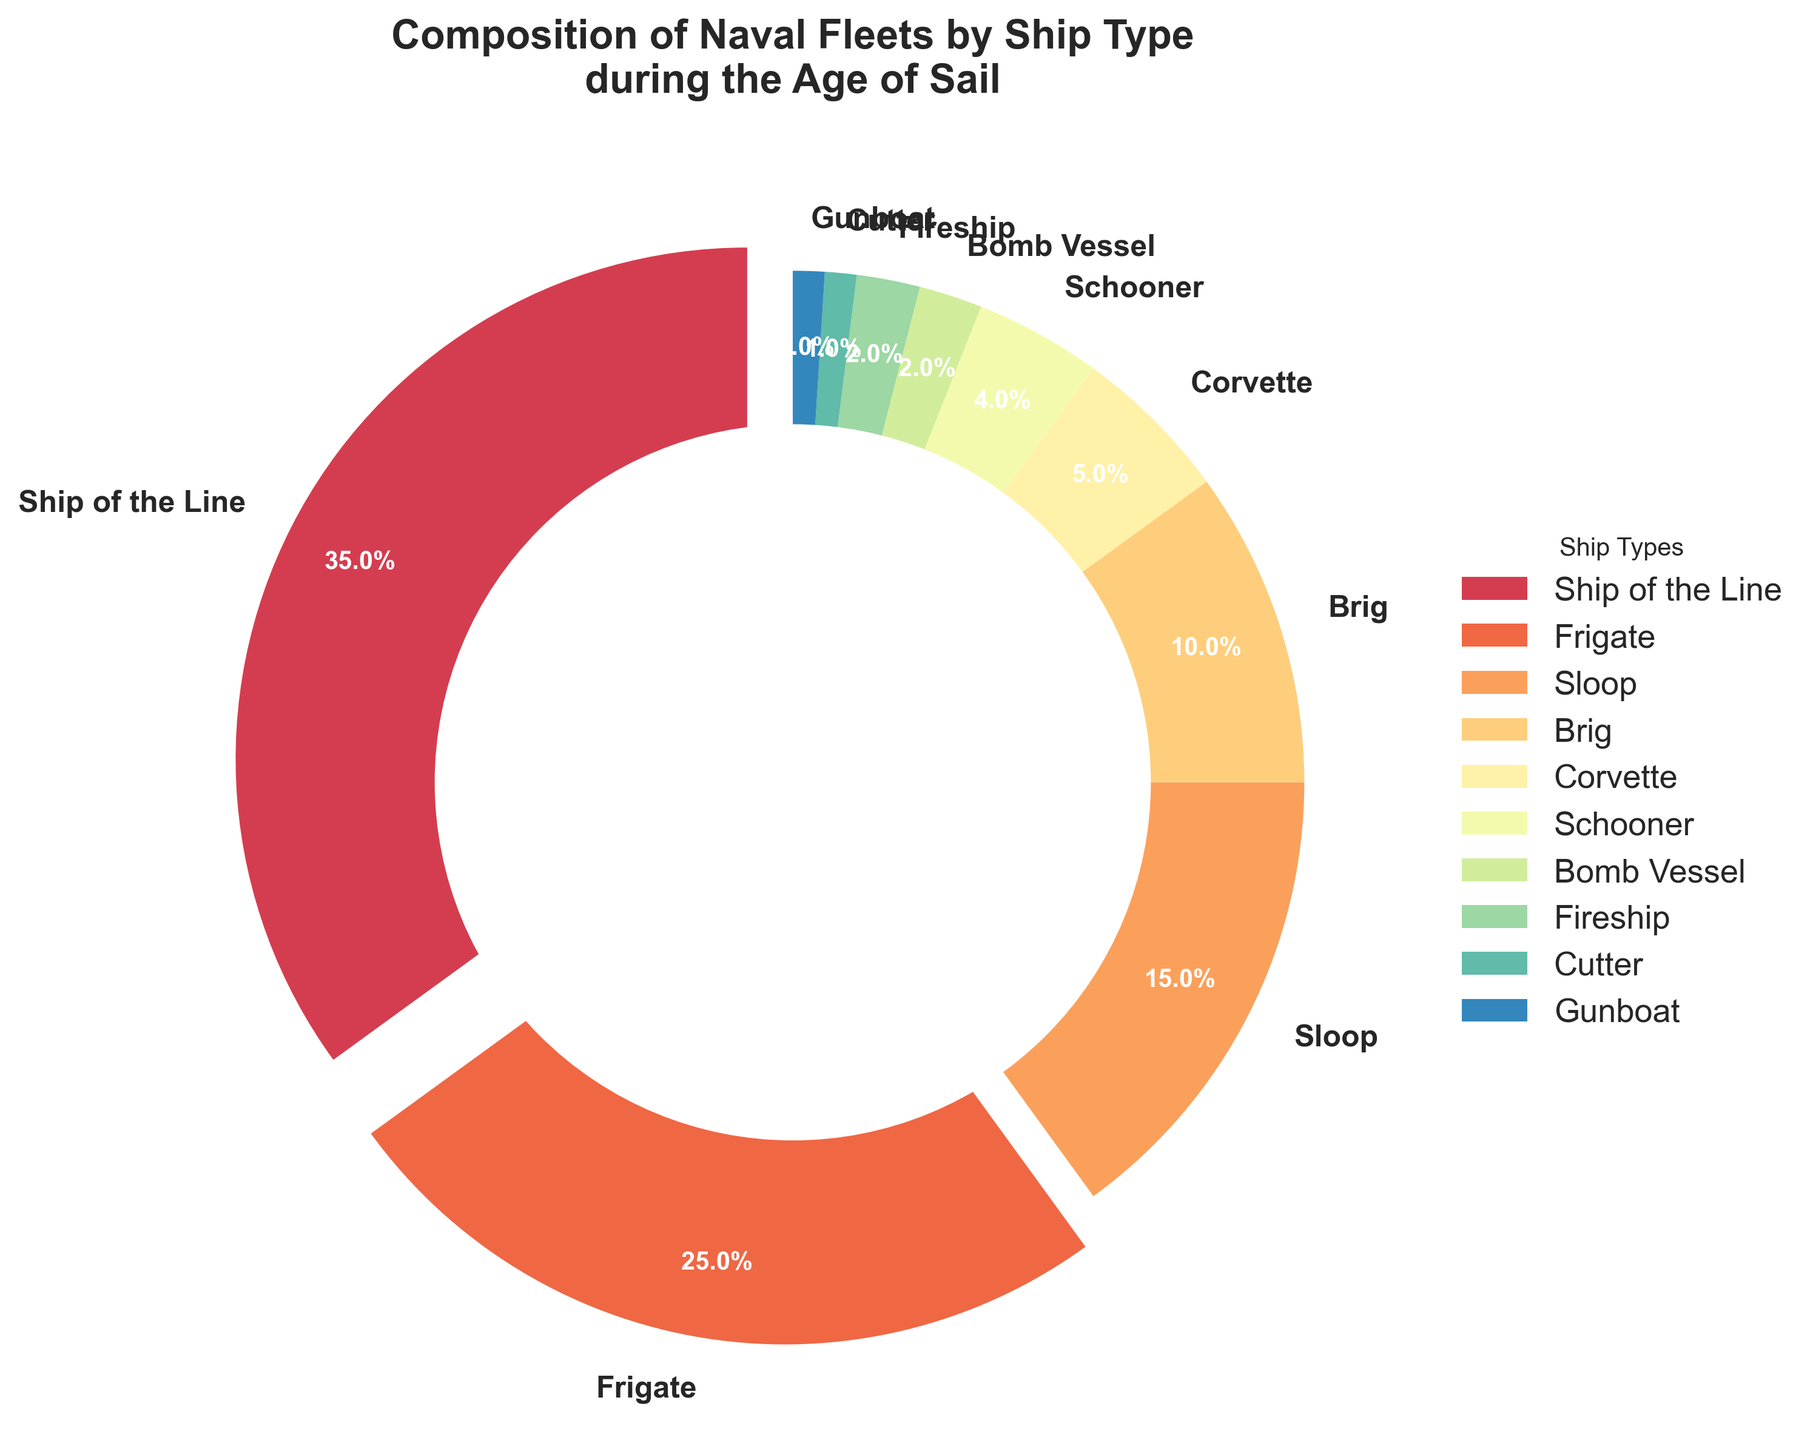What percentage of the naval fleet is comprised of Ships of the Line and Frigates combined? Sum the percentages of Ships of the Line and Frigates: 35% + 25% = 60%
Answer: 60% Which ship type has the second smallest representation in the fleet? The Cutter and Gunboat both have the smallest percentages (1%). The next smallest representation is Bomb Vessel at 2%.
Answer: Bomb Vessel Are there more Frigates or Brigs in the fleet? Compare the percentages: Frigates (25%) and Brigs (10%). Frigates have a higher percentage than Brigs.
Answer: Frigates What is the combined percentage of Sloop, Corvette, and Schooner types in the fleet? Sum the percentages of Sloop, Corvette, and Schooner: 15% + 5% + 4% = 24%
Answer: 24% Which two ship types have an equal percentage representation in the fleet? Check for ship types with the same percentages: Bomb Vessel (2%) and Fireship (2%) both have equal representation.
Answer: Bomb Vessel and Fireship How much larger is the percentage of Ships of the Line compared to Brigs? Subtract the percentage of Brigs from Ships of the Line: 35% - 10% = 25%
Answer: 25% What are the colors representing the two largest ship types in the fleet? The two largest ship types are Ships of the Line and Frigates. Visually identify their colors from the pie chart, which are colors at the beginning of the spectral colormap.
Answer: Two colors at the beginning of the spectral colormap Which ship type constitutes more than a quarter of the fleet? Only Ships of the Line have a percentage greater than 25%: specifically, 35%.
Answer: Ships of the Line What is the difference in percentage representation between the largest and smallest ship types? Subtract the smallest percentage from the largest: Ships of the Line (35%) - Cutter/Gunboat (1%) = 34%
Answer: 34% Are there any ship types with exactly 5% representation? Identify the ship type with a 5% slice in the pie chart, which is Corvette.
Answer: Corvette 